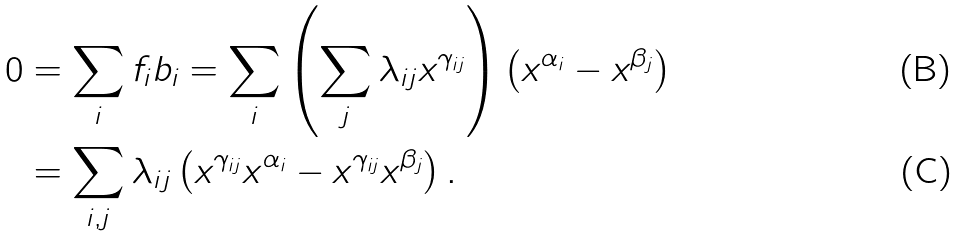Convert formula to latex. <formula><loc_0><loc_0><loc_500><loc_500>0 & = \sum _ { i } f _ { i } b _ { i } = \sum _ { i } \left ( \sum _ { j } \lambda _ { i j } x ^ { \gamma _ { i j } } \right ) \left ( x ^ { \alpha _ { i } } - x ^ { \beta _ { j } } \right ) \\ & = \sum _ { i , j } \lambda _ { i j } \left ( x ^ { \gamma _ { i j } } x ^ { \alpha _ { i } } - x ^ { \gamma _ { i j } } x ^ { \beta _ { j } } \right ) .</formula> 